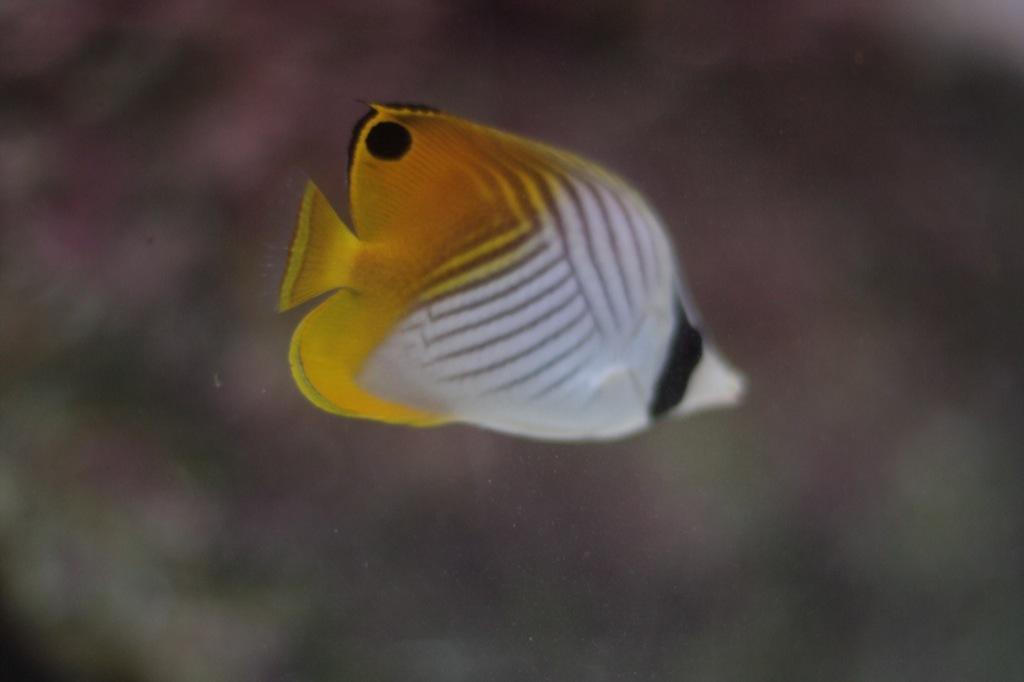Describe this image in one or two sentences. In the image we can see the fish, white, yellow and black in color and the background is blurred. 